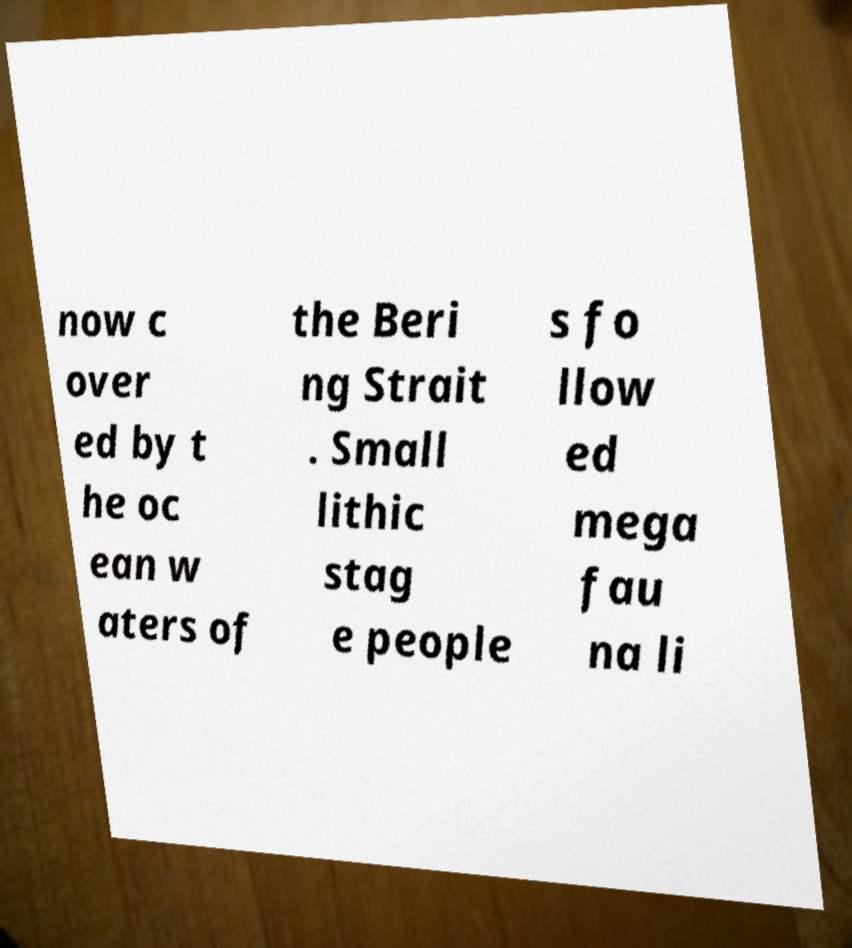Can you accurately transcribe the text from the provided image for me? now c over ed by t he oc ean w aters of the Beri ng Strait . Small lithic stag e people s fo llow ed mega fau na li 